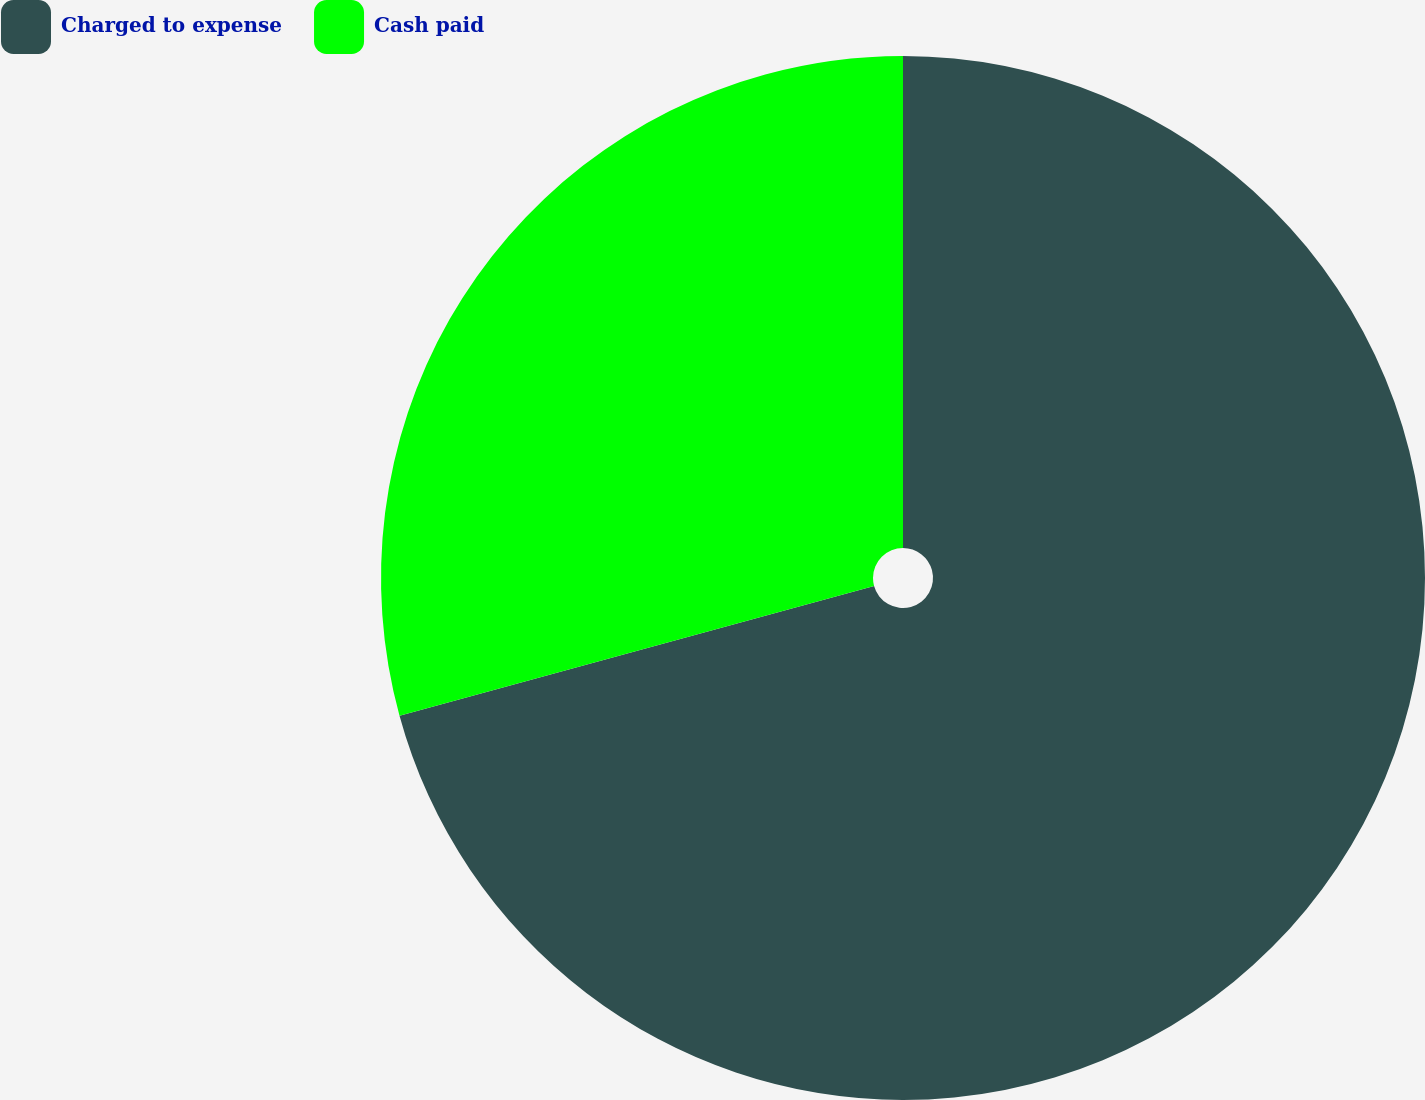Convert chart to OTSL. <chart><loc_0><loc_0><loc_500><loc_500><pie_chart><fcel>Charged to expense<fcel>Cash paid<nl><fcel>70.75%<fcel>29.25%<nl></chart> 